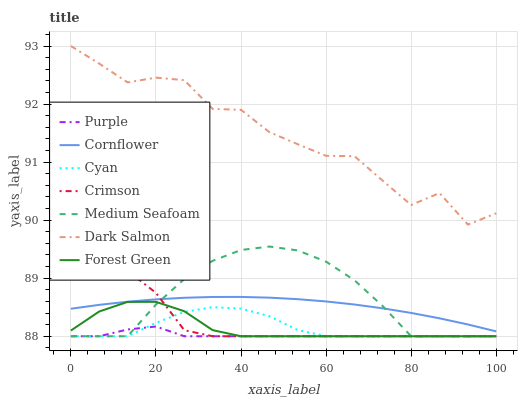Does Purple have the minimum area under the curve?
Answer yes or no. Yes. Does Dark Salmon have the maximum area under the curve?
Answer yes or no. Yes. Does Dark Salmon have the minimum area under the curve?
Answer yes or no. No. Does Purple have the maximum area under the curve?
Answer yes or no. No. Is Cornflower the smoothest?
Answer yes or no. Yes. Is Dark Salmon the roughest?
Answer yes or no. Yes. Is Purple the smoothest?
Answer yes or no. No. Is Purple the roughest?
Answer yes or no. No. Does Purple have the lowest value?
Answer yes or no. Yes. Does Dark Salmon have the lowest value?
Answer yes or no. No. Does Dark Salmon have the highest value?
Answer yes or no. Yes. Does Purple have the highest value?
Answer yes or no. No. Is Crimson less than Dark Salmon?
Answer yes or no. Yes. Is Dark Salmon greater than Forest Green?
Answer yes or no. Yes. Does Medium Seafoam intersect Purple?
Answer yes or no. Yes. Is Medium Seafoam less than Purple?
Answer yes or no. No. Is Medium Seafoam greater than Purple?
Answer yes or no. No. Does Crimson intersect Dark Salmon?
Answer yes or no. No. 